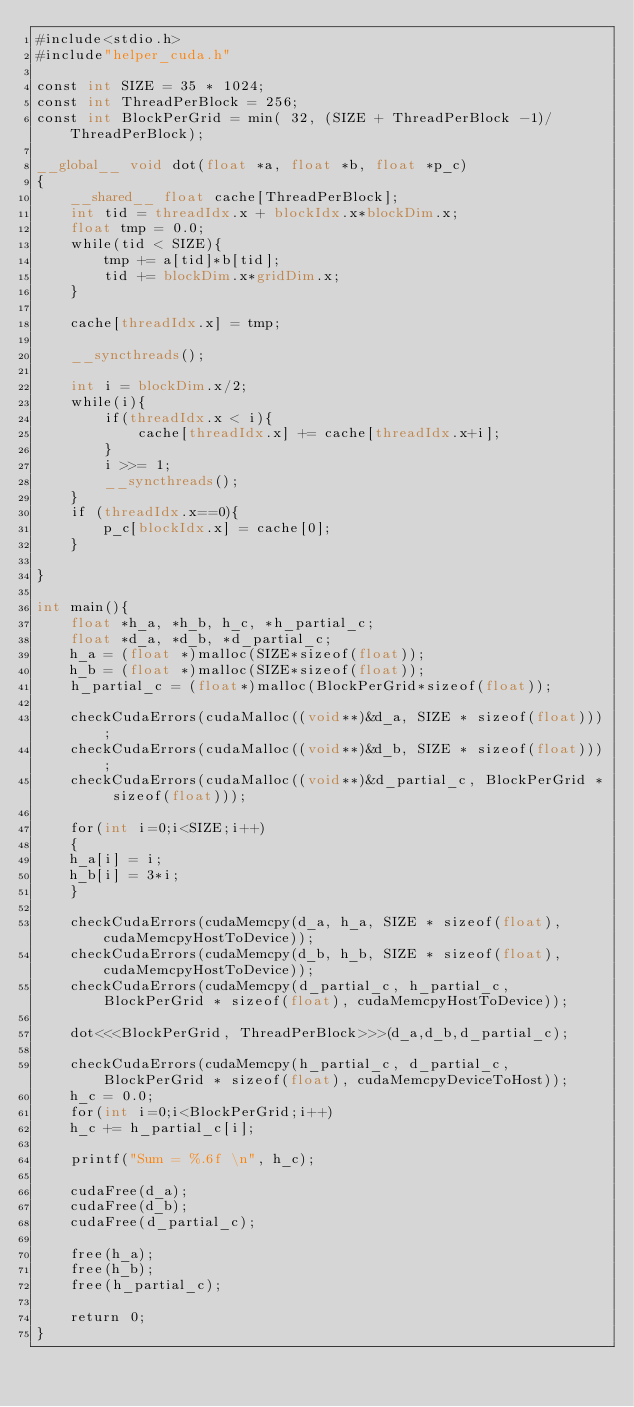Convert code to text. <code><loc_0><loc_0><loc_500><loc_500><_Cuda_>#include<stdio.h>
#include"helper_cuda.h"

const int SIZE = 35 * 1024;
const int ThreadPerBlock = 256;
const int BlockPerGrid = min( 32, (SIZE + ThreadPerBlock -1)/ThreadPerBlock);

__global__ void dot(float *a, float *b, float *p_c)
{
    __shared__ float cache[ThreadPerBlock];
    int tid = threadIdx.x + blockIdx.x*blockDim.x;
    float tmp = 0.0;
    while(tid < SIZE){
        tmp += a[tid]*b[tid];
        tid += blockDim.x*gridDim.x;
    }

    cache[threadIdx.x] = tmp;

    __syncthreads();

    int i = blockDim.x/2;
    while(i){
        if(threadIdx.x < i){
            cache[threadIdx.x] += cache[threadIdx.x+i];
        }
        i >>= 1;
        __syncthreads();
    }
    if (threadIdx.x==0){
        p_c[blockIdx.x] = cache[0];
    }

}

int main(){
    float *h_a, *h_b, h_c, *h_partial_c;
    float *d_a, *d_b, *d_partial_c;
    h_a = (float *)malloc(SIZE*sizeof(float));
    h_b = (float *)malloc(SIZE*sizeof(float));
    h_partial_c = (float*)malloc(BlockPerGrid*sizeof(float));

    checkCudaErrors(cudaMalloc((void**)&d_a, SIZE * sizeof(float)));
    checkCudaErrors(cudaMalloc((void**)&d_b, SIZE * sizeof(float)));
    checkCudaErrors(cudaMalloc((void**)&d_partial_c, BlockPerGrid * sizeof(float)));

    for(int i=0;i<SIZE;i++)
    {
    h_a[i] = i;
    h_b[i] = 3*i;
    }

    checkCudaErrors(cudaMemcpy(d_a, h_a, SIZE * sizeof(float), cudaMemcpyHostToDevice)); 
    checkCudaErrors(cudaMemcpy(d_b, h_b, SIZE * sizeof(float), cudaMemcpyHostToDevice)); 
    checkCudaErrors(cudaMemcpy(d_partial_c, h_partial_c, BlockPerGrid * sizeof(float), cudaMemcpyHostToDevice)); 

    dot<<<BlockPerGrid, ThreadPerBlock>>>(d_a,d_b,d_partial_c);

    checkCudaErrors(cudaMemcpy(h_partial_c, d_partial_c, BlockPerGrid * sizeof(float), cudaMemcpyDeviceToHost)); 
    h_c = 0.0;
    for(int i=0;i<BlockPerGrid;i++)
    h_c += h_partial_c[i];
    
    printf("Sum = %.6f \n", h_c);

    cudaFree(d_a);
    cudaFree(d_b);
    cudaFree(d_partial_c);

    free(h_a);
    free(h_b);
    free(h_partial_c);

    return 0;
}
</code> 